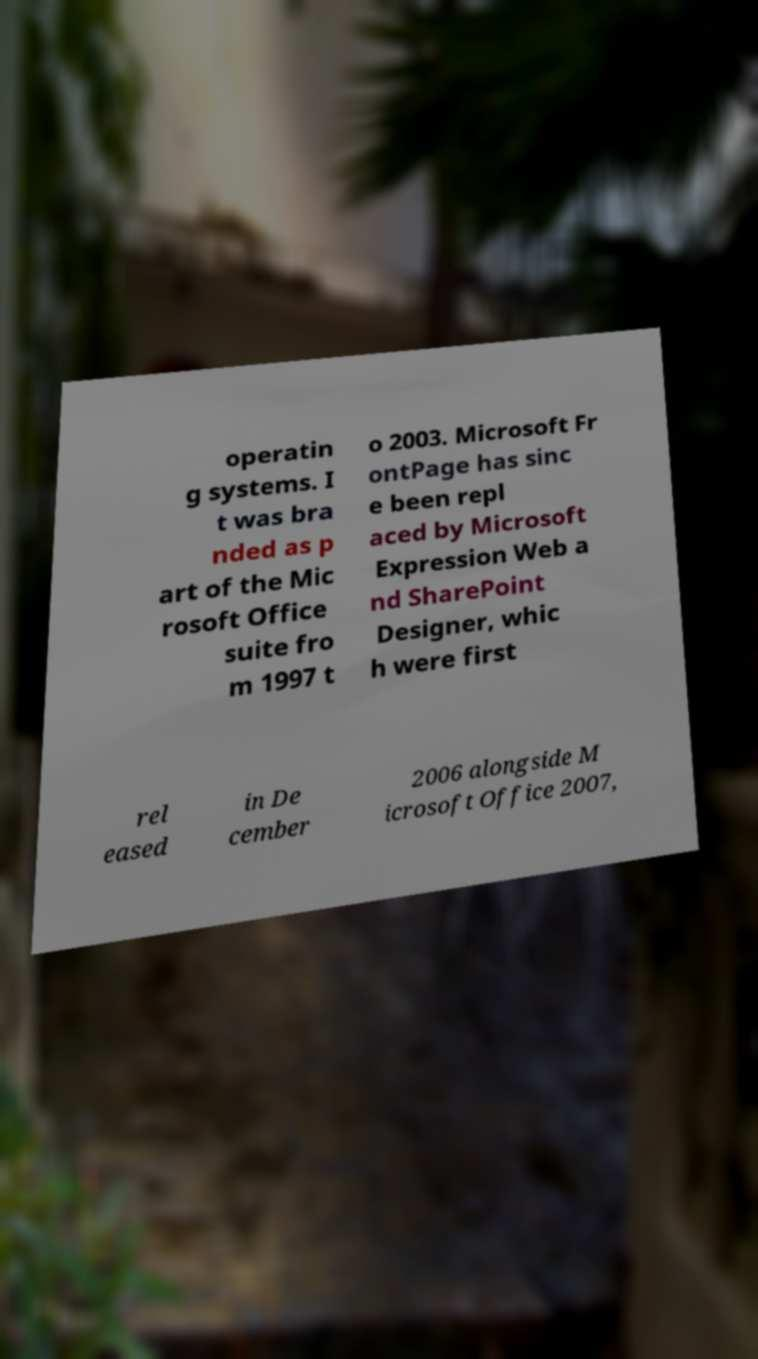Please read and relay the text visible in this image. What does it say? operatin g systems. I t was bra nded as p art of the Mic rosoft Office suite fro m 1997 t o 2003. Microsoft Fr ontPage has sinc e been repl aced by Microsoft Expression Web a nd SharePoint Designer, whic h were first rel eased in De cember 2006 alongside M icrosoft Office 2007, 